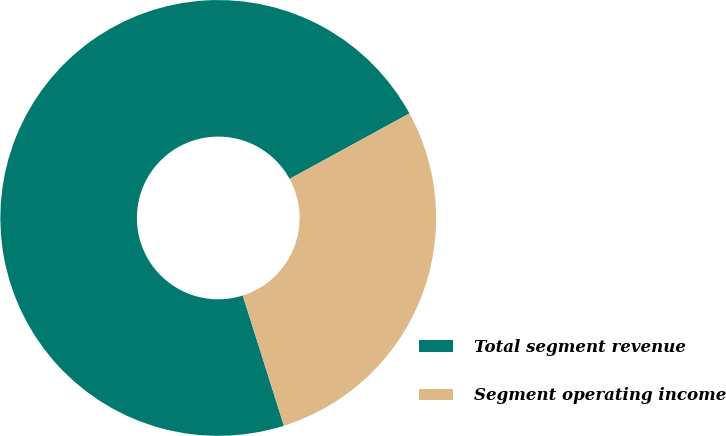Convert chart. <chart><loc_0><loc_0><loc_500><loc_500><pie_chart><fcel>Total segment revenue<fcel>Segment operating income<nl><fcel>71.91%<fcel>28.09%<nl></chart> 